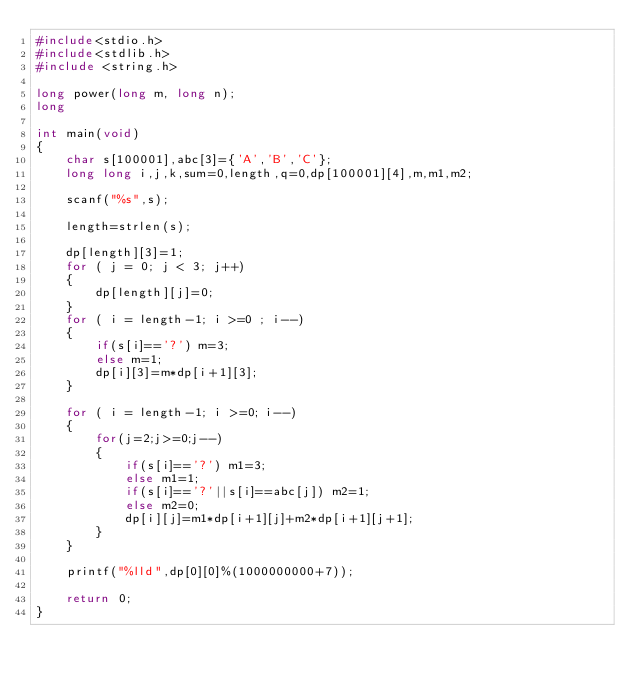Convert code to text. <code><loc_0><loc_0><loc_500><loc_500><_C_>#include<stdio.h>
#include<stdlib.h>
#include <string.h>

long power(long m, long n);
long

int main(void)
{
    char s[100001],abc[3]={'A','B','C'};
    long long i,j,k,sum=0,length,q=0,dp[100001][4],m,m1,m2;
    
    scanf("%s",s);

    length=strlen(s);

    dp[length][3]=1;
    for ( j = 0; j < 3; j++)
    {
        dp[length][j]=0;
    }
    for ( i = length-1; i >=0 ; i--)
    {
        if(s[i]=='?') m=3;
        else m=1;
        dp[i][3]=m*dp[i+1][3];
    }

    for ( i = length-1; i >=0; i--)
    {
        for(j=2;j>=0;j--)
        {
            if(s[i]=='?') m1=3;
            else m1=1;
            if(s[i]=='?'||s[i]==abc[j]) m2=1;
            else m2=0;
            dp[i][j]=m1*dp[i+1][j]+m2*dp[i+1][j+1];
        }
    }

    printf("%lld",dp[0][0]%(1000000000+7));

    return 0;
}</code> 